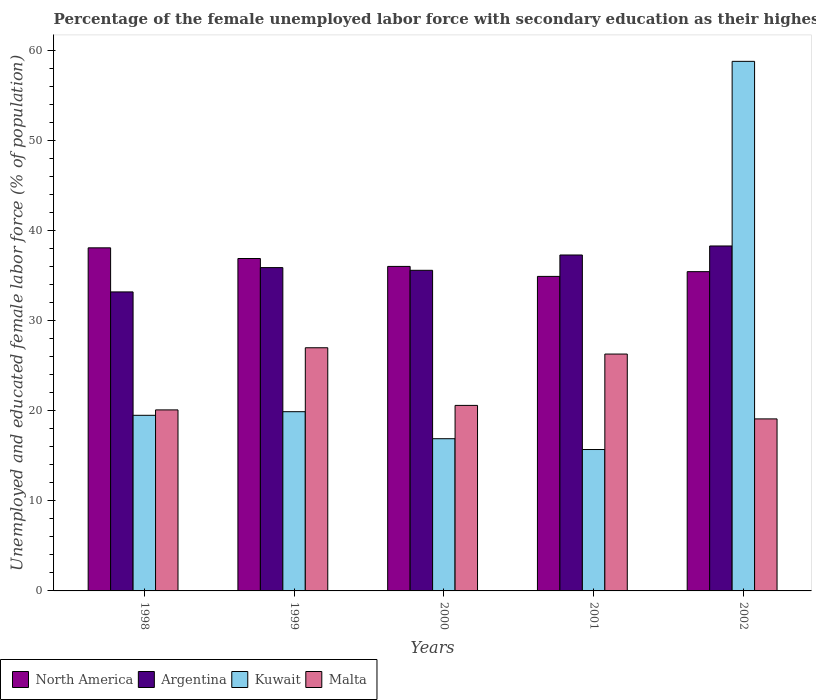How many groups of bars are there?
Keep it short and to the point. 5. Are the number of bars per tick equal to the number of legend labels?
Ensure brevity in your answer.  Yes. Are the number of bars on each tick of the X-axis equal?
Provide a succinct answer. Yes. How many bars are there on the 3rd tick from the right?
Keep it short and to the point. 4. In how many cases, is the number of bars for a given year not equal to the number of legend labels?
Ensure brevity in your answer.  0. What is the percentage of the unemployed female labor force with secondary education in Malta in 2000?
Your answer should be very brief. 20.6. Across all years, what is the maximum percentage of the unemployed female labor force with secondary education in Argentina?
Provide a short and direct response. 38.3. Across all years, what is the minimum percentage of the unemployed female labor force with secondary education in Kuwait?
Provide a succinct answer. 15.7. In which year was the percentage of the unemployed female labor force with secondary education in Argentina minimum?
Provide a succinct answer. 1998. What is the total percentage of the unemployed female labor force with secondary education in Kuwait in the graph?
Offer a very short reply. 130.8. What is the difference between the percentage of the unemployed female labor force with secondary education in Kuwait in 2000 and that in 2002?
Offer a terse response. -41.9. What is the difference between the percentage of the unemployed female labor force with secondary education in Malta in 2001 and the percentage of the unemployed female labor force with secondary education in Argentina in 2002?
Give a very brief answer. -12. What is the average percentage of the unemployed female labor force with secondary education in Argentina per year?
Ensure brevity in your answer.  36.06. In the year 1999, what is the difference between the percentage of the unemployed female labor force with secondary education in North America and percentage of the unemployed female labor force with secondary education in Malta?
Offer a very short reply. 9.91. What is the ratio of the percentage of the unemployed female labor force with secondary education in Argentina in 1998 to that in 2000?
Provide a short and direct response. 0.93. Is the percentage of the unemployed female labor force with secondary education in Kuwait in 1999 less than that in 2000?
Offer a very short reply. No. Is the difference between the percentage of the unemployed female labor force with secondary education in North America in 2000 and 2002 greater than the difference between the percentage of the unemployed female labor force with secondary education in Malta in 2000 and 2002?
Provide a succinct answer. No. What is the difference between the highest and the second highest percentage of the unemployed female labor force with secondary education in North America?
Offer a very short reply. 1.19. What is the difference between the highest and the lowest percentage of the unemployed female labor force with secondary education in Malta?
Your response must be concise. 7.9. Is the sum of the percentage of the unemployed female labor force with secondary education in Malta in 2001 and 2002 greater than the maximum percentage of the unemployed female labor force with secondary education in North America across all years?
Give a very brief answer. Yes. What does the 3rd bar from the left in 2001 represents?
Your response must be concise. Kuwait. What does the 4th bar from the right in 2002 represents?
Make the answer very short. North America. Is it the case that in every year, the sum of the percentage of the unemployed female labor force with secondary education in Argentina and percentage of the unemployed female labor force with secondary education in North America is greater than the percentage of the unemployed female labor force with secondary education in Kuwait?
Your response must be concise. Yes. How many bars are there?
Make the answer very short. 20. What is the difference between two consecutive major ticks on the Y-axis?
Keep it short and to the point. 10. Does the graph contain grids?
Give a very brief answer. No. Where does the legend appear in the graph?
Ensure brevity in your answer.  Bottom left. How are the legend labels stacked?
Your response must be concise. Horizontal. What is the title of the graph?
Keep it short and to the point. Percentage of the female unemployed labor force with secondary education as their highest grade. Does "European Union" appear as one of the legend labels in the graph?
Offer a very short reply. No. What is the label or title of the Y-axis?
Ensure brevity in your answer.  Unemployed and educated female labor force (% of population). What is the Unemployed and educated female labor force (% of population) of North America in 1998?
Your answer should be very brief. 38.09. What is the Unemployed and educated female labor force (% of population) in Argentina in 1998?
Your answer should be compact. 33.2. What is the Unemployed and educated female labor force (% of population) in Kuwait in 1998?
Ensure brevity in your answer.  19.5. What is the Unemployed and educated female labor force (% of population) of Malta in 1998?
Your answer should be compact. 20.1. What is the Unemployed and educated female labor force (% of population) of North America in 1999?
Your answer should be very brief. 36.91. What is the Unemployed and educated female labor force (% of population) of Argentina in 1999?
Give a very brief answer. 35.9. What is the Unemployed and educated female labor force (% of population) of Kuwait in 1999?
Provide a succinct answer. 19.9. What is the Unemployed and educated female labor force (% of population) of Malta in 1999?
Provide a short and direct response. 27. What is the Unemployed and educated female labor force (% of population) of North America in 2000?
Offer a very short reply. 36.03. What is the Unemployed and educated female labor force (% of population) of Argentina in 2000?
Your response must be concise. 35.6. What is the Unemployed and educated female labor force (% of population) of Kuwait in 2000?
Offer a terse response. 16.9. What is the Unemployed and educated female labor force (% of population) in Malta in 2000?
Your response must be concise. 20.6. What is the Unemployed and educated female labor force (% of population) in North America in 2001?
Your answer should be very brief. 34.92. What is the Unemployed and educated female labor force (% of population) of Argentina in 2001?
Your answer should be compact. 37.3. What is the Unemployed and educated female labor force (% of population) in Kuwait in 2001?
Ensure brevity in your answer.  15.7. What is the Unemployed and educated female labor force (% of population) of Malta in 2001?
Make the answer very short. 26.3. What is the Unemployed and educated female labor force (% of population) in North America in 2002?
Ensure brevity in your answer.  35.45. What is the Unemployed and educated female labor force (% of population) in Argentina in 2002?
Offer a terse response. 38.3. What is the Unemployed and educated female labor force (% of population) of Kuwait in 2002?
Your answer should be compact. 58.8. What is the Unemployed and educated female labor force (% of population) in Malta in 2002?
Offer a very short reply. 19.1. Across all years, what is the maximum Unemployed and educated female labor force (% of population) of North America?
Provide a succinct answer. 38.09. Across all years, what is the maximum Unemployed and educated female labor force (% of population) of Argentina?
Provide a short and direct response. 38.3. Across all years, what is the maximum Unemployed and educated female labor force (% of population) in Kuwait?
Offer a very short reply. 58.8. Across all years, what is the minimum Unemployed and educated female labor force (% of population) of North America?
Provide a succinct answer. 34.92. Across all years, what is the minimum Unemployed and educated female labor force (% of population) of Argentina?
Give a very brief answer. 33.2. Across all years, what is the minimum Unemployed and educated female labor force (% of population) of Kuwait?
Your answer should be compact. 15.7. Across all years, what is the minimum Unemployed and educated female labor force (% of population) of Malta?
Provide a short and direct response. 19.1. What is the total Unemployed and educated female labor force (% of population) in North America in the graph?
Make the answer very short. 181.41. What is the total Unemployed and educated female labor force (% of population) in Argentina in the graph?
Ensure brevity in your answer.  180.3. What is the total Unemployed and educated female labor force (% of population) of Kuwait in the graph?
Your answer should be compact. 130.8. What is the total Unemployed and educated female labor force (% of population) of Malta in the graph?
Provide a short and direct response. 113.1. What is the difference between the Unemployed and educated female labor force (% of population) in North America in 1998 and that in 1999?
Offer a terse response. 1.19. What is the difference between the Unemployed and educated female labor force (% of population) of Argentina in 1998 and that in 1999?
Keep it short and to the point. -2.7. What is the difference between the Unemployed and educated female labor force (% of population) in Kuwait in 1998 and that in 1999?
Offer a very short reply. -0.4. What is the difference between the Unemployed and educated female labor force (% of population) in North America in 1998 and that in 2000?
Provide a succinct answer. 2.06. What is the difference between the Unemployed and educated female labor force (% of population) of Argentina in 1998 and that in 2000?
Your answer should be very brief. -2.4. What is the difference between the Unemployed and educated female labor force (% of population) of Kuwait in 1998 and that in 2000?
Provide a short and direct response. 2.6. What is the difference between the Unemployed and educated female labor force (% of population) in Malta in 1998 and that in 2000?
Make the answer very short. -0.5. What is the difference between the Unemployed and educated female labor force (% of population) in North America in 1998 and that in 2001?
Keep it short and to the point. 3.17. What is the difference between the Unemployed and educated female labor force (% of population) in Kuwait in 1998 and that in 2001?
Your answer should be very brief. 3.8. What is the difference between the Unemployed and educated female labor force (% of population) in Malta in 1998 and that in 2001?
Your response must be concise. -6.2. What is the difference between the Unemployed and educated female labor force (% of population) of North America in 1998 and that in 2002?
Make the answer very short. 2.64. What is the difference between the Unemployed and educated female labor force (% of population) of Argentina in 1998 and that in 2002?
Give a very brief answer. -5.1. What is the difference between the Unemployed and educated female labor force (% of population) in Kuwait in 1998 and that in 2002?
Your response must be concise. -39.3. What is the difference between the Unemployed and educated female labor force (% of population) in Malta in 1998 and that in 2002?
Make the answer very short. 1. What is the difference between the Unemployed and educated female labor force (% of population) in North America in 1999 and that in 2000?
Make the answer very short. 0.88. What is the difference between the Unemployed and educated female labor force (% of population) of North America in 1999 and that in 2001?
Make the answer very short. 1.99. What is the difference between the Unemployed and educated female labor force (% of population) in Kuwait in 1999 and that in 2001?
Offer a very short reply. 4.2. What is the difference between the Unemployed and educated female labor force (% of population) of Malta in 1999 and that in 2001?
Give a very brief answer. 0.7. What is the difference between the Unemployed and educated female labor force (% of population) in North America in 1999 and that in 2002?
Your answer should be very brief. 1.46. What is the difference between the Unemployed and educated female labor force (% of population) in Kuwait in 1999 and that in 2002?
Ensure brevity in your answer.  -38.9. What is the difference between the Unemployed and educated female labor force (% of population) in Malta in 1999 and that in 2002?
Provide a succinct answer. 7.9. What is the difference between the Unemployed and educated female labor force (% of population) of North America in 2000 and that in 2001?
Your answer should be compact. 1.11. What is the difference between the Unemployed and educated female labor force (% of population) in Argentina in 2000 and that in 2001?
Keep it short and to the point. -1.7. What is the difference between the Unemployed and educated female labor force (% of population) of North America in 2000 and that in 2002?
Your response must be concise. 0.58. What is the difference between the Unemployed and educated female labor force (% of population) in Kuwait in 2000 and that in 2002?
Your answer should be very brief. -41.9. What is the difference between the Unemployed and educated female labor force (% of population) of Malta in 2000 and that in 2002?
Your answer should be compact. 1.5. What is the difference between the Unemployed and educated female labor force (% of population) in North America in 2001 and that in 2002?
Your answer should be very brief. -0.53. What is the difference between the Unemployed and educated female labor force (% of population) of Kuwait in 2001 and that in 2002?
Your response must be concise. -43.1. What is the difference between the Unemployed and educated female labor force (% of population) of Malta in 2001 and that in 2002?
Give a very brief answer. 7.2. What is the difference between the Unemployed and educated female labor force (% of population) of North America in 1998 and the Unemployed and educated female labor force (% of population) of Argentina in 1999?
Ensure brevity in your answer.  2.19. What is the difference between the Unemployed and educated female labor force (% of population) of North America in 1998 and the Unemployed and educated female labor force (% of population) of Kuwait in 1999?
Give a very brief answer. 18.19. What is the difference between the Unemployed and educated female labor force (% of population) in North America in 1998 and the Unemployed and educated female labor force (% of population) in Malta in 1999?
Keep it short and to the point. 11.09. What is the difference between the Unemployed and educated female labor force (% of population) of Argentina in 1998 and the Unemployed and educated female labor force (% of population) of Malta in 1999?
Keep it short and to the point. 6.2. What is the difference between the Unemployed and educated female labor force (% of population) of North America in 1998 and the Unemployed and educated female labor force (% of population) of Argentina in 2000?
Keep it short and to the point. 2.49. What is the difference between the Unemployed and educated female labor force (% of population) of North America in 1998 and the Unemployed and educated female labor force (% of population) of Kuwait in 2000?
Give a very brief answer. 21.19. What is the difference between the Unemployed and educated female labor force (% of population) in North America in 1998 and the Unemployed and educated female labor force (% of population) in Malta in 2000?
Make the answer very short. 17.49. What is the difference between the Unemployed and educated female labor force (% of population) of North America in 1998 and the Unemployed and educated female labor force (% of population) of Argentina in 2001?
Provide a short and direct response. 0.79. What is the difference between the Unemployed and educated female labor force (% of population) in North America in 1998 and the Unemployed and educated female labor force (% of population) in Kuwait in 2001?
Your response must be concise. 22.39. What is the difference between the Unemployed and educated female labor force (% of population) in North America in 1998 and the Unemployed and educated female labor force (% of population) in Malta in 2001?
Offer a terse response. 11.79. What is the difference between the Unemployed and educated female labor force (% of population) of Kuwait in 1998 and the Unemployed and educated female labor force (% of population) of Malta in 2001?
Your answer should be compact. -6.8. What is the difference between the Unemployed and educated female labor force (% of population) in North America in 1998 and the Unemployed and educated female labor force (% of population) in Argentina in 2002?
Your answer should be compact. -0.21. What is the difference between the Unemployed and educated female labor force (% of population) in North America in 1998 and the Unemployed and educated female labor force (% of population) in Kuwait in 2002?
Your answer should be very brief. -20.71. What is the difference between the Unemployed and educated female labor force (% of population) in North America in 1998 and the Unemployed and educated female labor force (% of population) in Malta in 2002?
Ensure brevity in your answer.  18.99. What is the difference between the Unemployed and educated female labor force (% of population) of Argentina in 1998 and the Unemployed and educated female labor force (% of population) of Kuwait in 2002?
Make the answer very short. -25.6. What is the difference between the Unemployed and educated female labor force (% of population) of Argentina in 1998 and the Unemployed and educated female labor force (% of population) of Malta in 2002?
Your response must be concise. 14.1. What is the difference between the Unemployed and educated female labor force (% of population) of North America in 1999 and the Unemployed and educated female labor force (% of population) of Argentina in 2000?
Give a very brief answer. 1.31. What is the difference between the Unemployed and educated female labor force (% of population) in North America in 1999 and the Unemployed and educated female labor force (% of population) in Kuwait in 2000?
Your answer should be very brief. 20.01. What is the difference between the Unemployed and educated female labor force (% of population) in North America in 1999 and the Unemployed and educated female labor force (% of population) in Malta in 2000?
Your answer should be compact. 16.31. What is the difference between the Unemployed and educated female labor force (% of population) of Kuwait in 1999 and the Unemployed and educated female labor force (% of population) of Malta in 2000?
Provide a succinct answer. -0.7. What is the difference between the Unemployed and educated female labor force (% of population) in North America in 1999 and the Unemployed and educated female labor force (% of population) in Argentina in 2001?
Offer a terse response. -0.39. What is the difference between the Unemployed and educated female labor force (% of population) of North America in 1999 and the Unemployed and educated female labor force (% of population) of Kuwait in 2001?
Your answer should be compact. 21.21. What is the difference between the Unemployed and educated female labor force (% of population) in North America in 1999 and the Unemployed and educated female labor force (% of population) in Malta in 2001?
Ensure brevity in your answer.  10.61. What is the difference between the Unemployed and educated female labor force (% of population) of Argentina in 1999 and the Unemployed and educated female labor force (% of population) of Kuwait in 2001?
Your answer should be very brief. 20.2. What is the difference between the Unemployed and educated female labor force (% of population) in Argentina in 1999 and the Unemployed and educated female labor force (% of population) in Malta in 2001?
Offer a terse response. 9.6. What is the difference between the Unemployed and educated female labor force (% of population) in North America in 1999 and the Unemployed and educated female labor force (% of population) in Argentina in 2002?
Offer a terse response. -1.39. What is the difference between the Unemployed and educated female labor force (% of population) of North America in 1999 and the Unemployed and educated female labor force (% of population) of Kuwait in 2002?
Give a very brief answer. -21.89. What is the difference between the Unemployed and educated female labor force (% of population) of North America in 1999 and the Unemployed and educated female labor force (% of population) of Malta in 2002?
Provide a succinct answer. 17.81. What is the difference between the Unemployed and educated female labor force (% of population) in Argentina in 1999 and the Unemployed and educated female labor force (% of population) in Kuwait in 2002?
Your answer should be compact. -22.9. What is the difference between the Unemployed and educated female labor force (% of population) in Kuwait in 1999 and the Unemployed and educated female labor force (% of population) in Malta in 2002?
Ensure brevity in your answer.  0.8. What is the difference between the Unemployed and educated female labor force (% of population) of North America in 2000 and the Unemployed and educated female labor force (% of population) of Argentina in 2001?
Your response must be concise. -1.27. What is the difference between the Unemployed and educated female labor force (% of population) in North America in 2000 and the Unemployed and educated female labor force (% of population) in Kuwait in 2001?
Your answer should be compact. 20.33. What is the difference between the Unemployed and educated female labor force (% of population) of North America in 2000 and the Unemployed and educated female labor force (% of population) of Malta in 2001?
Your answer should be very brief. 9.73. What is the difference between the Unemployed and educated female labor force (% of population) of North America in 2000 and the Unemployed and educated female labor force (% of population) of Argentina in 2002?
Make the answer very short. -2.27. What is the difference between the Unemployed and educated female labor force (% of population) of North America in 2000 and the Unemployed and educated female labor force (% of population) of Kuwait in 2002?
Give a very brief answer. -22.77. What is the difference between the Unemployed and educated female labor force (% of population) of North America in 2000 and the Unemployed and educated female labor force (% of population) of Malta in 2002?
Keep it short and to the point. 16.93. What is the difference between the Unemployed and educated female labor force (% of population) of Argentina in 2000 and the Unemployed and educated female labor force (% of population) of Kuwait in 2002?
Give a very brief answer. -23.2. What is the difference between the Unemployed and educated female labor force (% of population) of North America in 2001 and the Unemployed and educated female labor force (% of population) of Argentina in 2002?
Provide a short and direct response. -3.38. What is the difference between the Unemployed and educated female labor force (% of population) in North America in 2001 and the Unemployed and educated female labor force (% of population) in Kuwait in 2002?
Ensure brevity in your answer.  -23.88. What is the difference between the Unemployed and educated female labor force (% of population) of North America in 2001 and the Unemployed and educated female labor force (% of population) of Malta in 2002?
Offer a very short reply. 15.82. What is the difference between the Unemployed and educated female labor force (% of population) in Argentina in 2001 and the Unemployed and educated female labor force (% of population) in Kuwait in 2002?
Your response must be concise. -21.5. What is the difference between the Unemployed and educated female labor force (% of population) in Argentina in 2001 and the Unemployed and educated female labor force (% of population) in Malta in 2002?
Provide a short and direct response. 18.2. What is the difference between the Unemployed and educated female labor force (% of population) of Kuwait in 2001 and the Unemployed and educated female labor force (% of population) of Malta in 2002?
Offer a terse response. -3.4. What is the average Unemployed and educated female labor force (% of population) of North America per year?
Make the answer very short. 36.28. What is the average Unemployed and educated female labor force (% of population) of Argentina per year?
Offer a terse response. 36.06. What is the average Unemployed and educated female labor force (% of population) of Kuwait per year?
Offer a terse response. 26.16. What is the average Unemployed and educated female labor force (% of population) of Malta per year?
Your response must be concise. 22.62. In the year 1998, what is the difference between the Unemployed and educated female labor force (% of population) in North America and Unemployed and educated female labor force (% of population) in Argentina?
Your response must be concise. 4.89. In the year 1998, what is the difference between the Unemployed and educated female labor force (% of population) in North America and Unemployed and educated female labor force (% of population) in Kuwait?
Keep it short and to the point. 18.59. In the year 1998, what is the difference between the Unemployed and educated female labor force (% of population) in North America and Unemployed and educated female labor force (% of population) in Malta?
Provide a short and direct response. 17.99. In the year 1999, what is the difference between the Unemployed and educated female labor force (% of population) in North America and Unemployed and educated female labor force (% of population) in Kuwait?
Your response must be concise. 17.01. In the year 1999, what is the difference between the Unemployed and educated female labor force (% of population) of North America and Unemployed and educated female labor force (% of population) of Malta?
Your response must be concise. 9.91. In the year 1999, what is the difference between the Unemployed and educated female labor force (% of population) of Argentina and Unemployed and educated female labor force (% of population) of Kuwait?
Your answer should be compact. 16. In the year 1999, what is the difference between the Unemployed and educated female labor force (% of population) of Argentina and Unemployed and educated female labor force (% of population) of Malta?
Your response must be concise. 8.9. In the year 2000, what is the difference between the Unemployed and educated female labor force (% of population) in North America and Unemployed and educated female labor force (% of population) in Argentina?
Make the answer very short. 0.43. In the year 2000, what is the difference between the Unemployed and educated female labor force (% of population) of North America and Unemployed and educated female labor force (% of population) of Kuwait?
Give a very brief answer. 19.13. In the year 2000, what is the difference between the Unemployed and educated female labor force (% of population) of North America and Unemployed and educated female labor force (% of population) of Malta?
Your answer should be very brief. 15.43. In the year 2000, what is the difference between the Unemployed and educated female labor force (% of population) in Argentina and Unemployed and educated female labor force (% of population) in Malta?
Give a very brief answer. 15. In the year 2001, what is the difference between the Unemployed and educated female labor force (% of population) in North America and Unemployed and educated female labor force (% of population) in Argentina?
Make the answer very short. -2.38. In the year 2001, what is the difference between the Unemployed and educated female labor force (% of population) of North America and Unemployed and educated female labor force (% of population) of Kuwait?
Offer a very short reply. 19.22. In the year 2001, what is the difference between the Unemployed and educated female labor force (% of population) of North America and Unemployed and educated female labor force (% of population) of Malta?
Make the answer very short. 8.62. In the year 2001, what is the difference between the Unemployed and educated female labor force (% of population) of Argentina and Unemployed and educated female labor force (% of population) of Kuwait?
Your response must be concise. 21.6. In the year 2002, what is the difference between the Unemployed and educated female labor force (% of population) of North America and Unemployed and educated female labor force (% of population) of Argentina?
Provide a succinct answer. -2.85. In the year 2002, what is the difference between the Unemployed and educated female labor force (% of population) in North America and Unemployed and educated female labor force (% of population) in Kuwait?
Your answer should be very brief. -23.35. In the year 2002, what is the difference between the Unemployed and educated female labor force (% of population) in North America and Unemployed and educated female labor force (% of population) in Malta?
Offer a terse response. 16.35. In the year 2002, what is the difference between the Unemployed and educated female labor force (% of population) in Argentina and Unemployed and educated female labor force (% of population) in Kuwait?
Your response must be concise. -20.5. In the year 2002, what is the difference between the Unemployed and educated female labor force (% of population) in Argentina and Unemployed and educated female labor force (% of population) in Malta?
Your answer should be compact. 19.2. In the year 2002, what is the difference between the Unemployed and educated female labor force (% of population) of Kuwait and Unemployed and educated female labor force (% of population) of Malta?
Give a very brief answer. 39.7. What is the ratio of the Unemployed and educated female labor force (% of population) in North America in 1998 to that in 1999?
Ensure brevity in your answer.  1.03. What is the ratio of the Unemployed and educated female labor force (% of population) of Argentina in 1998 to that in 1999?
Keep it short and to the point. 0.92. What is the ratio of the Unemployed and educated female labor force (% of population) in Kuwait in 1998 to that in 1999?
Offer a very short reply. 0.98. What is the ratio of the Unemployed and educated female labor force (% of population) of Malta in 1998 to that in 1999?
Keep it short and to the point. 0.74. What is the ratio of the Unemployed and educated female labor force (% of population) of North America in 1998 to that in 2000?
Provide a succinct answer. 1.06. What is the ratio of the Unemployed and educated female labor force (% of population) of Argentina in 1998 to that in 2000?
Ensure brevity in your answer.  0.93. What is the ratio of the Unemployed and educated female labor force (% of population) of Kuwait in 1998 to that in 2000?
Provide a short and direct response. 1.15. What is the ratio of the Unemployed and educated female labor force (% of population) in Malta in 1998 to that in 2000?
Keep it short and to the point. 0.98. What is the ratio of the Unemployed and educated female labor force (% of population) in North America in 1998 to that in 2001?
Make the answer very short. 1.09. What is the ratio of the Unemployed and educated female labor force (% of population) of Argentina in 1998 to that in 2001?
Offer a terse response. 0.89. What is the ratio of the Unemployed and educated female labor force (% of population) in Kuwait in 1998 to that in 2001?
Provide a short and direct response. 1.24. What is the ratio of the Unemployed and educated female labor force (% of population) in Malta in 1998 to that in 2001?
Your answer should be very brief. 0.76. What is the ratio of the Unemployed and educated female labor force (% of population) in North America in 1998 to that in 2002?
Your answer should be very brief. 1.07. What is the ratio of the Unemployed and educated female labor force (% of population) of Argentina in 1998 to that in 2002?
Provide a short and direct response. 0.87. What is the ratio of the Unemployed and educated female labor force (% of population) of Kuwait in 1998 to that in 2002?
Give a very brief answer. 0.33. What is the ratio of the Unemployed and educated female labor force (% of population) in Malta in 1998 to that in 2002?
Offer a very short reply. 1.05. What is the ratio of the Unemployed and educated female labor force (% of population) in North America in 1999 to that in 2000?
Provide a succinct answer. 1.02. What is the ratio of the Unemployed and educated female labor force (% of population) in Argentina in 1999 to that in 2000?
Offer a terse response. 1.01. What is the ratio of the Unemployed and educated female labor force (% of population) of Kuwait in 1999 to that in 2000?
Keep it short and to the point. 1.18. What is the ratio of the Unemployed and educated female labor force (% of population) of Malta in 1999 to that in 2000?
Offer a terse response. 1.31. What is the ratio of the Unemployed and educated female labor force (% of population) in North America in 1999 to that in 2001?
Provide a short and direct response. 1.06. What is the ratio of the Unemployed and educated female labor force (% of population) in Argentina in 1999 to that in 2001?
Your response must be concise. 0.96. What is the ratio of the Unemployed and educated female labor force (% of population) in Kuwait in 1999 to that in 2001?
Your answer should be compact. 1.27. What is the ratio of the Unemployed and educated female labor force (% of population) in Malta in 1999 to that in 2001?
Your answer should be very brief. 1.03. What is the ratio of the Unemployed and educated female labor force (% of population) of North America in 1999 to that in 2002?
Your answer should be very brief. 1.04. What is the ratio of the Unemployed and educated female labor force (% of population) in Argentina in 1999 to that in 2002?
Keep it short and to the point. 0.94. What is the ratio of the Unemployed and educated female labor force (% of population) in Kuwait in 1999 to that in 2002?
Give a very brief answer. 0.34. What is the ratio of the Unemployed and educated female labor force (% of population) in Malta in 1999 to that in 2002?
Offer a very short reply. 1.41. What is the ratio of the Unemployed and educated female labor force (% of population) of North America in 2000 to that in 2001?
Your response must be concise. 1.03. What is the ratio of the Unemployed and educated female labor force (% of population) of Argentina in 2000 to that in 2001?
Provide a short and direct response. 0.95. What is the ratio of the Unemployed and educated female labor force (% of population) in Kuwait in 2000 to that in 2001?
Provide a short and direct response. 1.08. What is the ratio of the Unemployed and educated female labor force (% of population) of Malta in 2000 to that in 2001?
Ensure brevity in your answer.  0.78. What is the ratio of the Unemployed and educated female labor force (% of population) of North America in 2000 to that in 2002?
Give a very brief answer. 1.02. What is the ratio of the Unemployed and educated female labor force (% of population) of Argentina in 2000 to that in 2002?
Your answer should be compact. 0.93. What is the ratio of the Unemployed and educated female labor force (% of population) in Kuwait in 2000 to that in 2002?
Your response must be concise. 0.29. What is the ratio of the Unemployed and educated female labor force (% of population) in Malta in 2000 to that in 2002?
Offer a very short reply. 1.08. What is the ratio of the Unemployed and educated female labor force (% of population) in North America in 2001 to that in 2002?
Ensure brevity in your answer.  0.99. What is the ratio of the Unemployed and educated female labor force (% of population) of Argentina in 2001 to that in 2002?
Your answer should be very brief. 0.97. What is the ratio of the Unemployed and educated female labor force (% of population) of Kuwait in 2001 to that in 2002?
Your answer should be compact. 0.27. What is the ratio of the Unemployed and educated female labor force (% of population) of Malta in 2001 to that in 2002?
Your answer should be compact. 1.38. What is the difference between the highest and the second highest Unemployed and educated female labor force (% of population) of North America?
Your answer should be very brief. 1.19. What is the difference between the highest and the second highest Unemployed and educated female labor force (% of population) of Argentina?
Keep it short and to the point. 1. What is the difference between the highest and the second highest Unemployed and educated female labor force (% of population) in Kuwait?
Make the answer very short. 38.9. What is the difference between the highest and the lowest Unemployed and educated female labor force (% of population) of North America?
Ensure brevity in your answer.  3.17. What is the difference between the highest and the lowest Unemployed and educated female labor force (% of population) in Kuwait?
Provide a succinct answer. 43.1. What is the difference between the highest and the lowest Unemployed and educated female labor force (% of population) in Malta?
Your answer should be very brief. 7.9. 